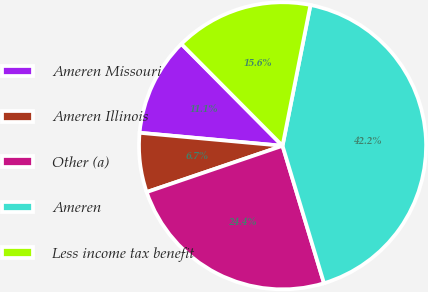<chart> <loc_0><loc_0><loc_500><loc_500><pie_chart><fcel>Ameren Missouri<fcel>Ameren Illinois<fcel>Other (a)<fcel>Ameren<fcel>Less income tax benefit<nl><fcel>11.11%<fcel>6.67%<fcel>24.44%<fcel>42.22%<fcel>15.56%<nl></chart> 